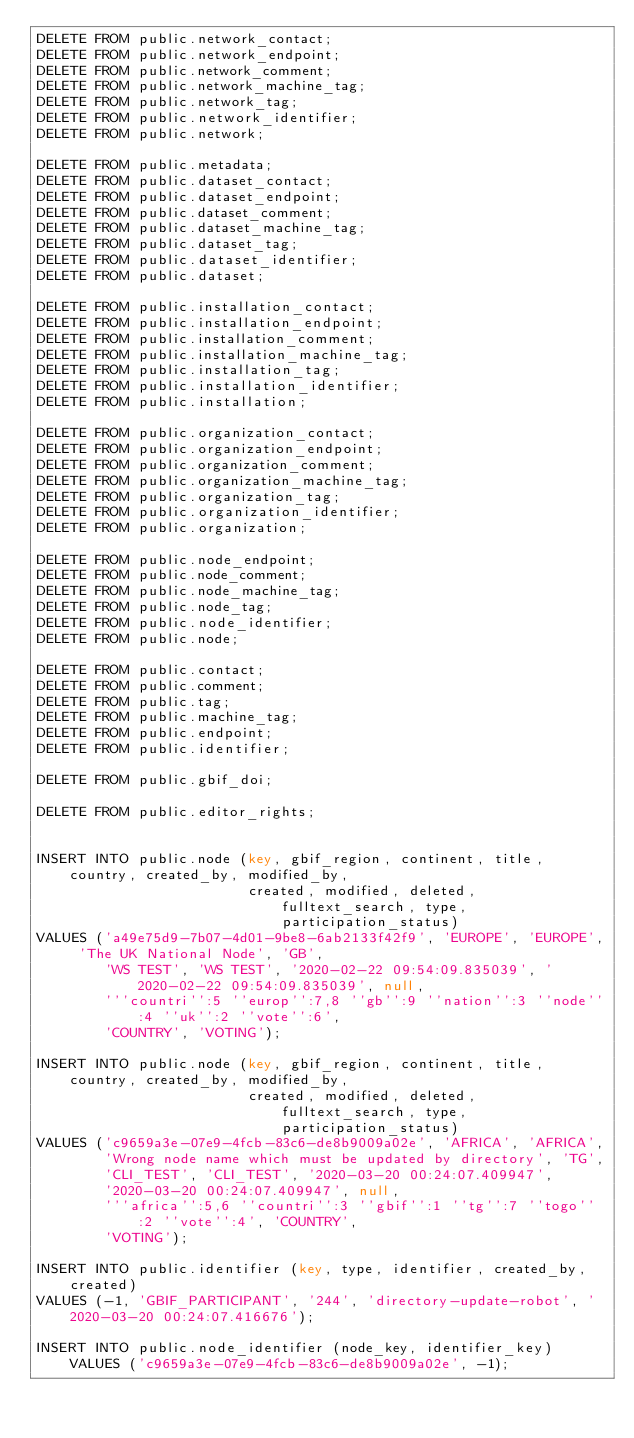Convert code to text. <code><loc_0><loc_0><loc_500><loc_500><_SQL_>DELETE FROM public.network_contact;
DELETE FROM public.network_endpoint;
DELETE FROM public.network_comment;
DELETE FROM public.network_machine_tag;
DELETE FROM public.network_tag;
DELETE FROM public.network_identifier;
DELETE FROM public.network;

DELETE FROM public.metadata;
DELETE FROM public.dataset_contact;
DELETE FROM public.dataset_endpoint;
DELETE FROM public.dataset_comment;
DELETE FROM public.dataset_machine_tag;
DELETE FROM public.dataset_tag;
DELETE FROM public.dataset_identifier;
DELETE FROM public.dataset;

DELETE FROM public.installation_contact;
DELETE FROM public.installation_endpoint;
DELETE FROM public.installation_comment;
DELETE FROM public.installation_machine_tag;
DELETE FROM public.installation_tag;
DELETE FROM public.installation_identifier;
DELETE FROM public.installation;

DELETE FROM public.organization_contact;
DELETE FROM public.organization_endpoint;
DELETE FROM public.organization_comment;
DELETE FROM public.organization_machine_tag;
DELETE FROM public.organization_tag;
DELETE FROM public.organization_identifier;
DELETE FROM public.organization;

DELETE FROM public.node_endpoint;
DELETE FROM public.node_comment;
DELETE FROM public.node_machine_tag;
DELETE FROM public.node_tag;
DELETE FROM public.node_identifier;
DELETE FROM public.node;

DELETE FROM public.contact;
DELETE FROM public.comment;
DELETE FROM public.tag;
DELETE FROM public.machine_tag;
DELETE FROM public.endpoint;
DELETE FROM public.identifier;

DELETE FROM public.gbif_doi;

DELETE FROM public.editor_rights;


INSERT INTO public.node (key, gbif_region, continent, title, country, created_by, modified_by,
                         created, modified, deleted, fulltext_search, type, participation_status)
VALUES ('a49e75d9-7b07-4d01-9be8-6ab2133f42f9', 'EUROPE', 'EUROPE', 'The UK National Node', 'GB',
        'WS TEST', 'WS TEST', '2020-02-22 09:54:09.835039', '2020-02-22 09:54:09.835039', null,
        '''countri'':5 ''europ'':7,8 ''gb'':9 ''nation'':3 ''node'':4 ''uk'':2 ''vote'':6',
        'COUNTRY', 'VOTING');

INSERT INTO public.node (key, gbif_region, continent, title, country, created_by, modified_by,
                         created, modified, deleted, fulltext_search, type, participation_status)
VALUES ('c9659a3e-07e9-4fcb-83c6-de8b9009a02e', 'AFRICA', 'AFRICA',
        'Wrong node name which must be updated by directory', 'TG',
        'CLI_TEST', 'CLI_TEST', '2020-03-20 00:24:07.409947',
        '2020-03-20 00:24:07.409947', null,
        '''africa'':5,6 ''countri'':3 ''gbif'':1 ''tg'':7 ''togo'':2 ''vote'':4', 'COUNTRY',
        'VOTING');

INSERT INTO public.identifier (key, type, identifier, created_by, created)
VALUES (-1, 'GBIF_PARTICIPANT', '244', 'directory-update-robot', '2020-03-20 00:24:07.416676');

INSERT INTO public.node_identifier (node_key, identifier_key) VALUES ('c9659a3e-07e9-4fcb-83c6-de8b9009a02e', -1);
</code> 